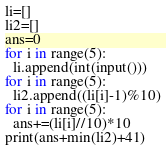<code> <loc_0><loc_0><loc_500><loc_500><_Python_>li=[]
li2=[]
ans=0
for i in range(5):
  li.append(int(input()))
for i in range(5):
  li2.append((li[i]-1)%10)
for i in range(5):
  ans+=(li[i]//10)*10
print(ans+min(li2)+41)
</code> 